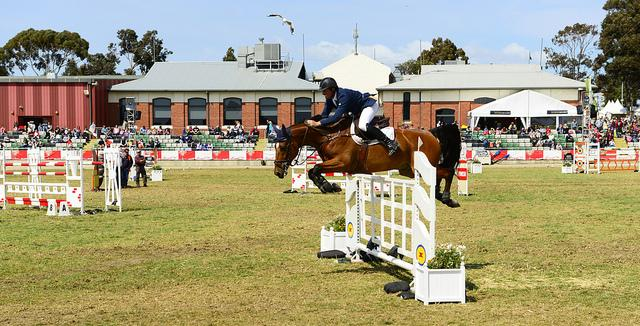What is the horse doing?

Choices:
A) sleeping
B) feeding
C) walking
D) leaping leaping 